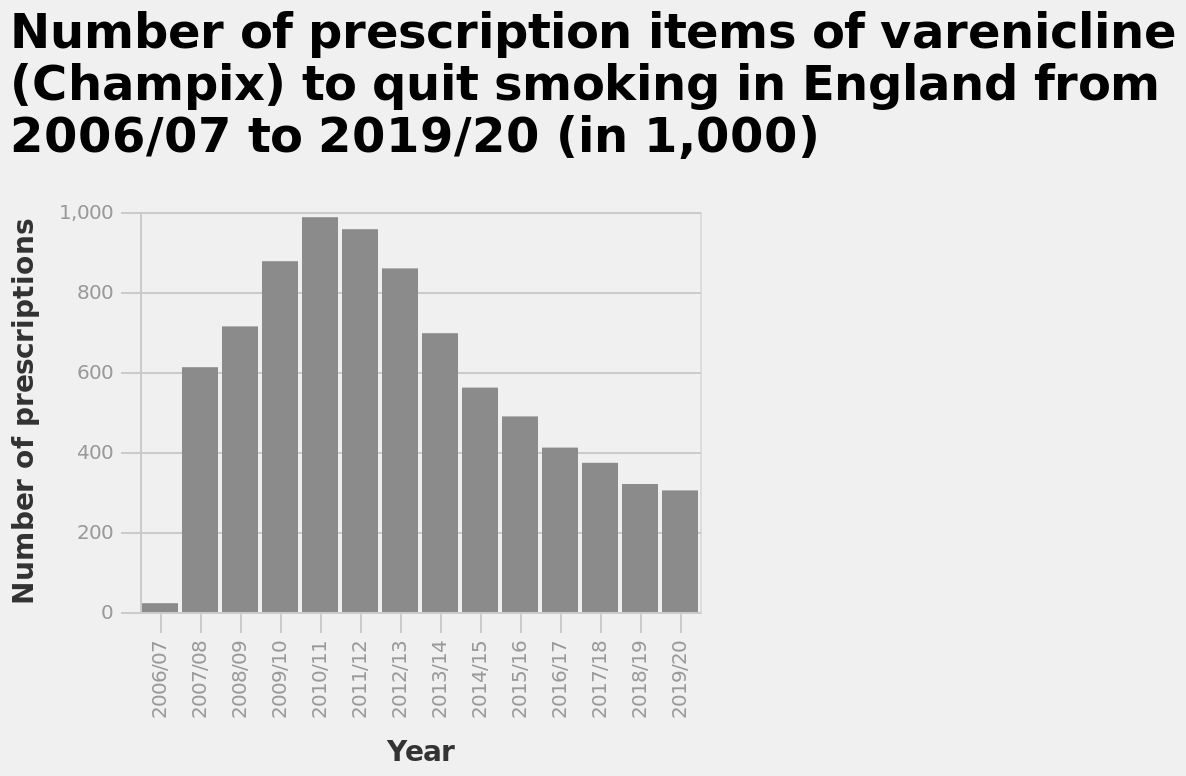<image>
Offer a thorough analysis of the image. The number of prescription items of varenicline (Champix) rose from 2006/2007 to 2010/2011. The number of prescription items of varenicline (Champix) was at its highest in 2010/2011 with 990~ prescriptions. The number of prescription items of varenicline (Champix) lowered from 2010/2011 to 2019/2020. In 2019/2020 the number of prescription items of varenicline (Champix) reached a low of 300~ prescriptions. The number of prescription items of varenicline (Champix) was at its lowest in 2006/2007 at 10~ prescriptions. What is the name of the bar plot?  The name of the bar plot is "Number of prescription items of varenicline (Champix) to quit smoking in England". How many prescription items of varenicline (Champix) were there in 2019/2020?  In 2019/2020, there were around 300~ prescription items of varenicline (Champix). Were there around 30 prescription items of varenicline (Champix) in 2019/2020? No. In 2019/2020, there were around 300~ prescription items of varenicline (Champix). 